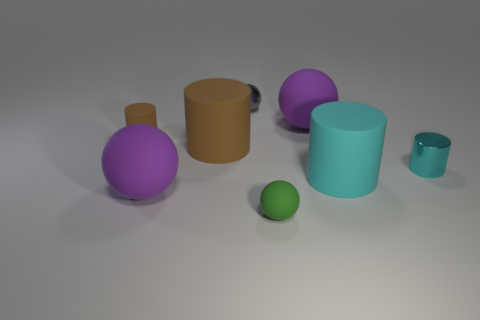Is the gray metal sphere the same size as the cyan rubber cylinder?
Your response must be concise. No. What is the small green object made of?
Provide a succinct answer. Rubber. There is a small ball that is the same material as the big cyan cylinder; what is its color?
Provide a succinct answer. Green. Does the small green sphere have the same material as the big ball that is to the right of the gray metal object?
Make the answer very short. Yes. What number of tiny cyan cylinders have the same material as the tiny gray object?
Keep it short and to the point. 1. There is a tiny metallic thing right of the small matte sphere; what is its shape?
Make the answer very short. Cylinder. Are the big purple thing that is on the left side of the big brown thing and the cyan thing in front of the metallic cylinder made of the same material?
Offer a very short reply. Yes. Is there a large yellow matte object that has the same shape as the big brown rubber object?
Ensure brevity in your answer.  No. How many things are green objects in front of the gray metallic ball or brown cylinders?
Give a very brief answer. 3. Are there more large balls that are to the left of the tiny gray metal sphere than small matte spheres on the left side of the big brown rubber cylinder?
Keep it short and to the point. Yes. 